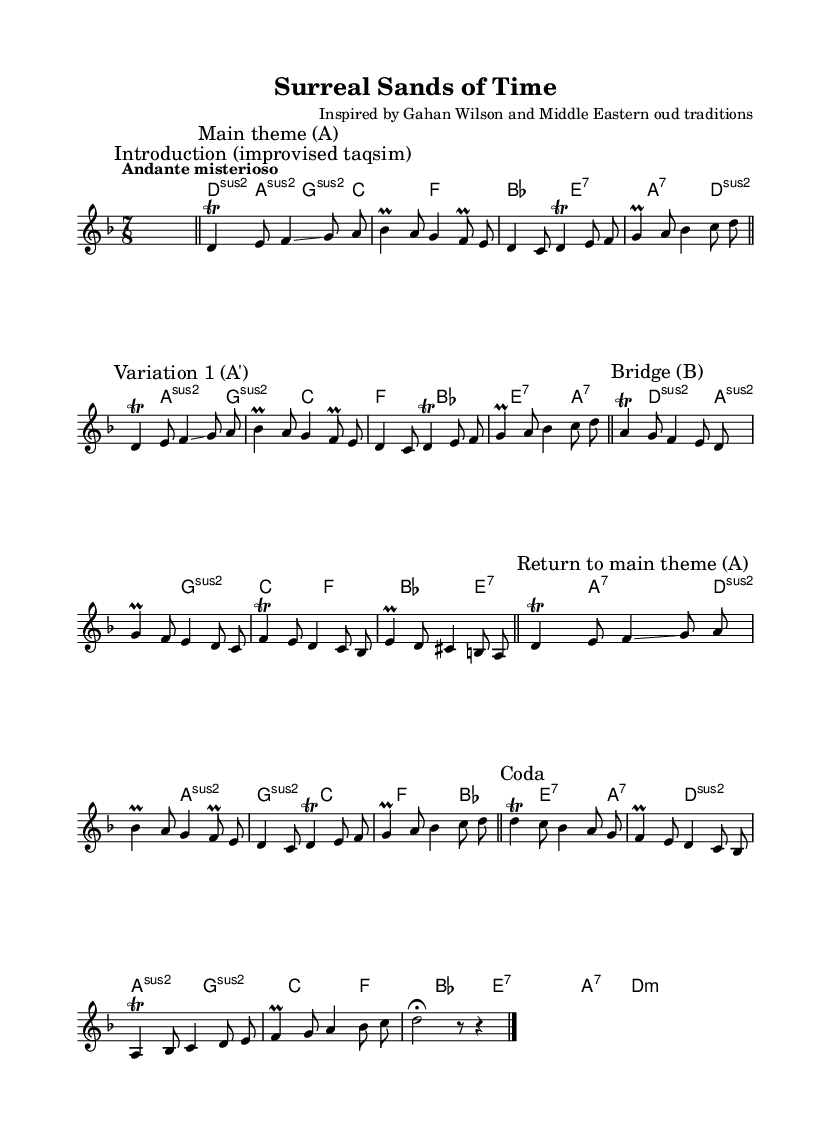What is the key signature of this music? The key signature indicates D minor, which has one flat (B flat). The presence of B flat in the measures confirms this signature.
Answer: D minor What is the time signature of the piece? The time signature is 7/8, as indicated at the beginning of the score. This means there are seven eighth notes in each measure.
Answer: 7/8 What is the tempo marking for this composition? The tempo marking is "Andante misterioso," suggesting a moderate and mysterious pace. This is stated at the top of the music score.
Answer: Andante misterioso How many variations are included in the piece? There are two variations indicated in the score: "Variation 1 (A')" and the "Main Theme (A)" is repeated. This can be derived from the section markings.
Answer: Two What musical technique is used with the notes in the main theme? The main theme incorporates trills and glissandos, as marked throughout the section. This involves rapid alternation and slides between notes.
Answer: Trills and glissandos What is the role of the "Bridge" section in this music? The "Bridge" section serves as a transition, which introduces new material that contrasts with the main theme, providing dynamic variety in the composition. This is standard in music composition to connect sections smoothly.
Answer: Transition What harmonic progression does the music primarily follow? The music primarily showcases minor and major chords, as seen in the chord progression, which indicates a reliance on the emotional weight typical of Middle Eastern music.
Answer: Minor and major chords 